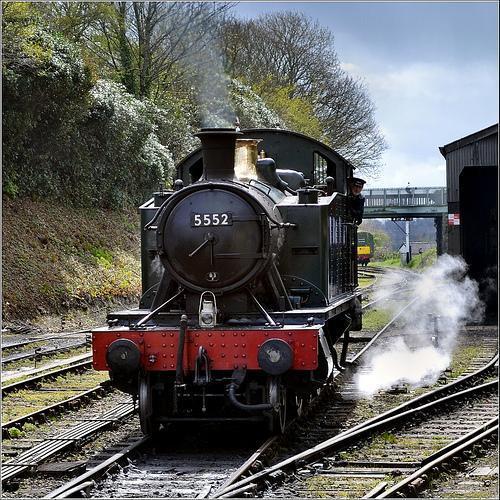How many cars are behind the engine?
Give a very brief answer. 0. How many headlights are on the train?
Give a very brief answer. 2. How many people can be seen?
Give a very brief answer. 1. 